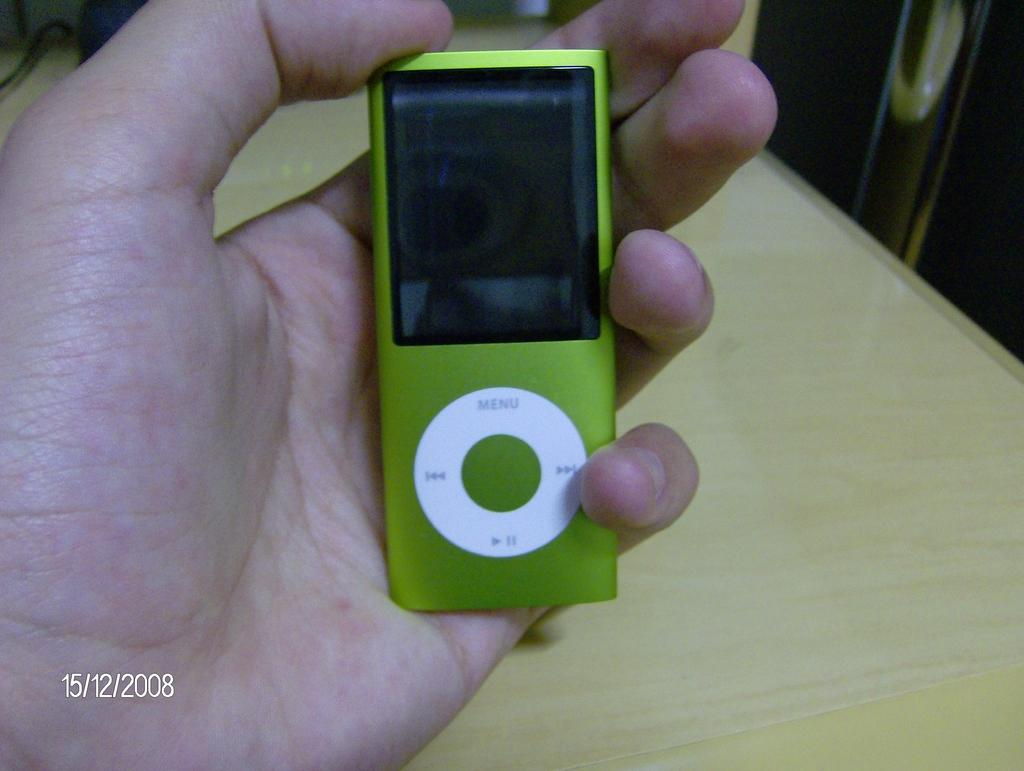What can be seen in the image? There is a person in the image. What is the person holding in the image? The person is holding an electronic gadget. Can you describe the appearance of the electronic gadget? The electronic gadget is green and white in color. Is the person in the image experiencing any wounds? There is no indication of any wounds on the person in the image. 